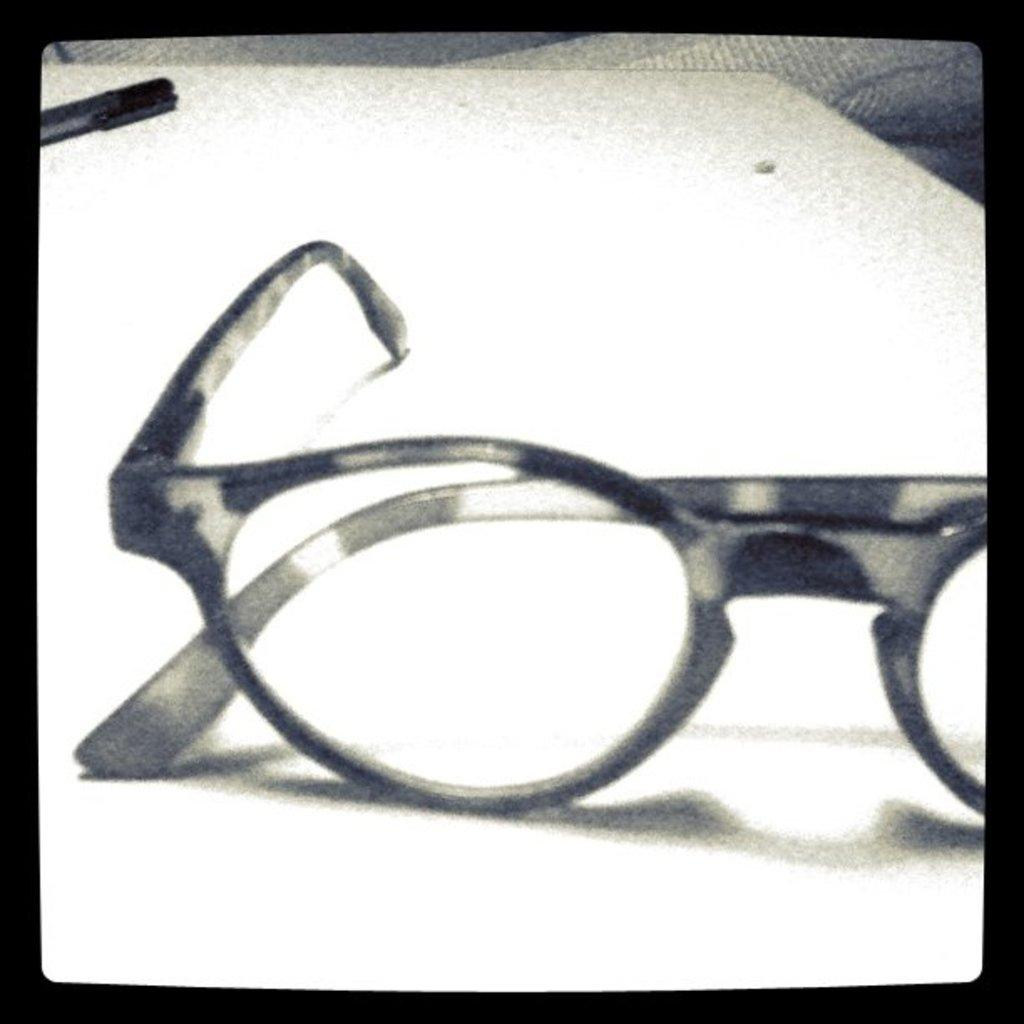What is placed on the white surface in the image? There are spectacles on a white surface. Can you describe any other objects in the image? There is a marker in the distance. What type of cave can be seen in the image? There is no cave present in the image; it only features spectacles on a white surface and a marker in the distance. What sound does the pan make in the image? There is no pan present in the image, so it cannot make any sound. 